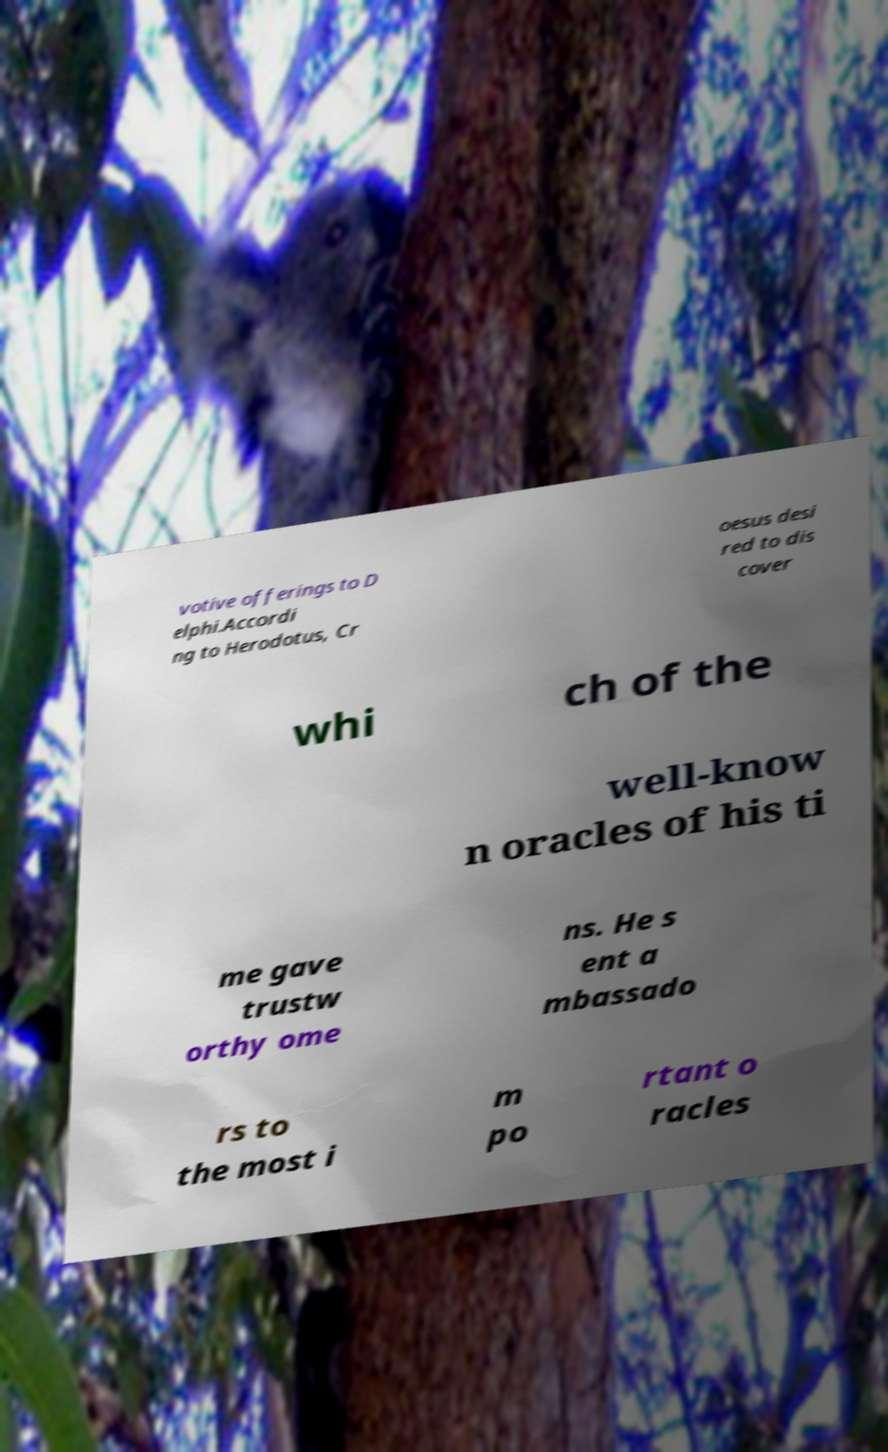Could you assist in decoding the text presented in this image and type it out clearly? votive offerings to D elphi.Accordi ng to Herodotus, Cr oesus desi red to dis cover whi ch of the well-know n oracles of his ti me gave trustw orthy ome ns. He s ent a mbassado rs to the most i m po rtant o racles 